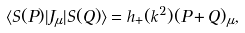<formula> <loc_0><loc_0><loc_500><loc_500>\langle S ( P ) | J _ { \mu } | S ( Q ) \rangle = h _ { + } ( k ^ { 2 } ) ( P + Q ) _ { \mu } ,</formula> 